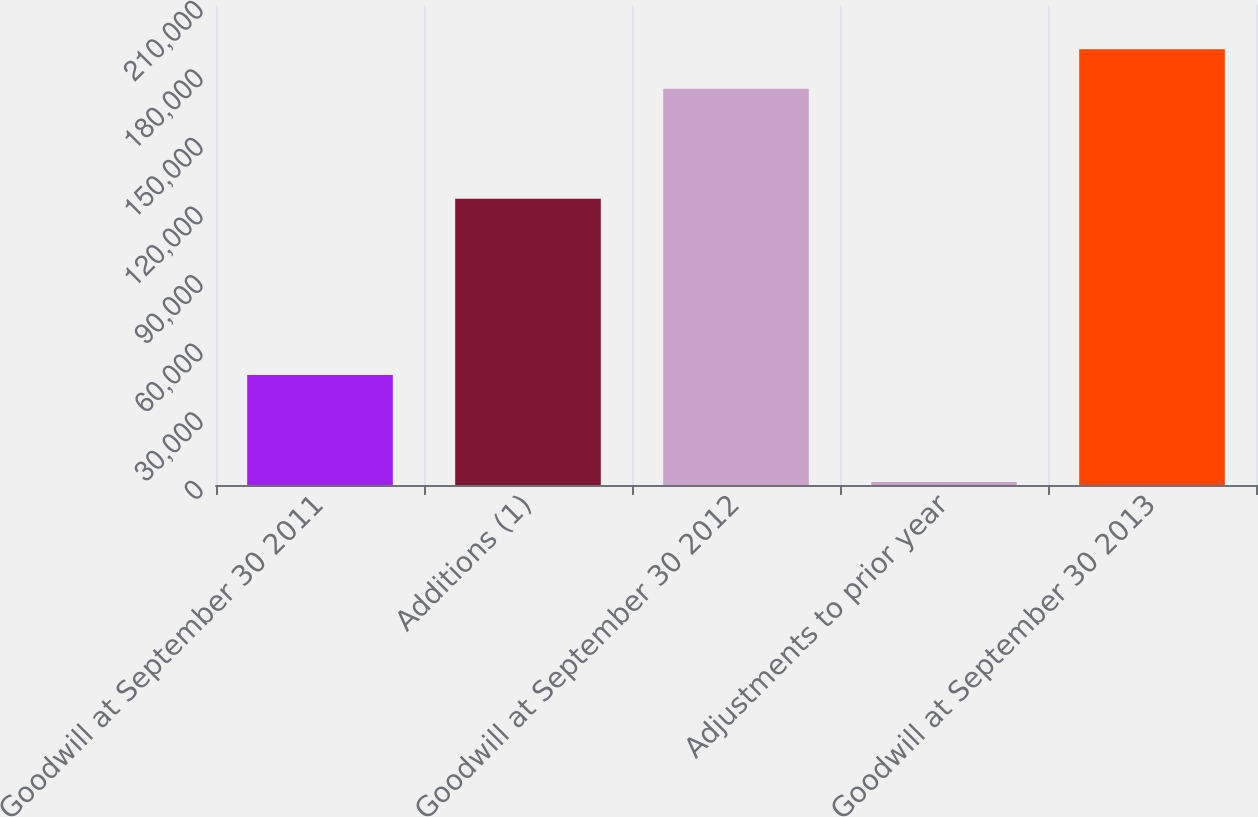Convert chart to OTSL. <chart><loc_0><loc_0><loc_500><loc_500><bar_chart><fcel>Goodwill at September 30 2011<fcel>Additions (1)<fcel>Goodwill at September 30 2012<fcel>Adjustments to prior year<fcel>Goodwill at September 30 2013<nl><fcel>48097<fcel>125220<fcel>173317<fcel>1267<fcel>190649<nl></chart> 